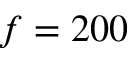Convert formula to latex. <formula><loc_0><loc_0><loc_500><loc_500>f = 2 0 0</formula> 